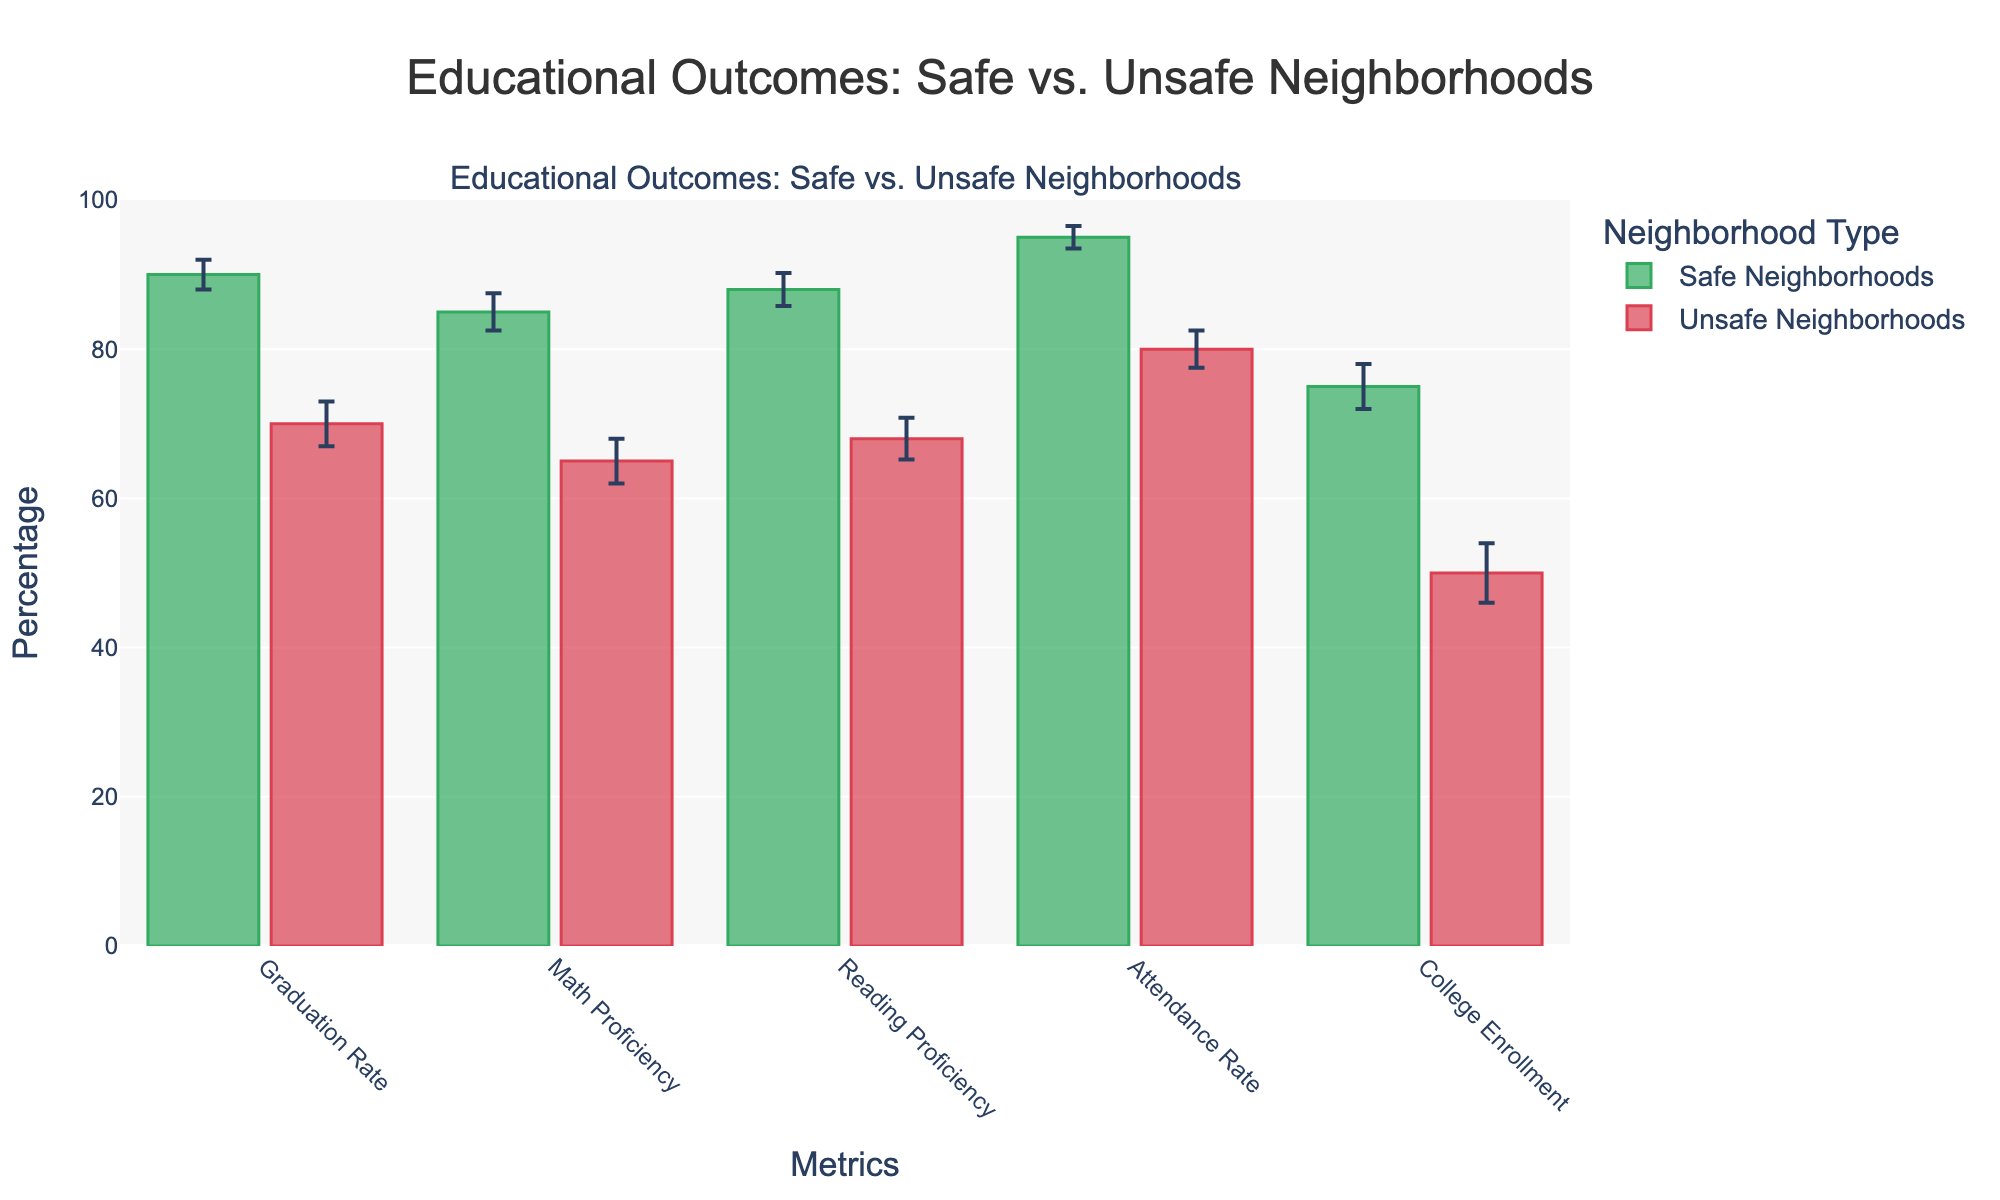What's the title of the figure? The title of the figure is typically displayed at the top and in larger fonts. In this figure, the title is: "Educational Outcomes: Safe vs. Unsafe Neighborhoods".
Answer: Educational Outcomes: Safe vs. Unsafe Neighborhoods What is the mean graduation rate for unsafe neighborhoods? The mean graduation rate for unsafe neighborhoods is shown as the height of the bar labeled "Graduation Rate" under the Unsafe group.
Answer: 70% How does the error bar for reading proficiency in unsafe neighborhoods compare to the error bar for reading proficiency in safe neighborhoods? To compare the error bars for reading proficiency, look at the lines extending vertically from the top of the bars for both safe and unsafe neighborhoods. The error bar in unsafe neighborhoods is larger (2.8) compared to safe neighborhoods (2.2).
Answer: The error bar is larger for unsafe neighborhoods Compare the attendance rates between safe and unsafe neighborhoods. The attendance rate for safe neighborhoods and unsafe neighborhoods is represented by the height of the respective bars. Safe neighborhoods have an attendance rate of 95%, and unsafe neighborhoods have an attendance rate of 80%.
Answer: Safe neighborhoods have a 15% higher attendance rate Which metric shows the smallest difference in means between safe and unsafe neighborhoods? To find this, examine the differences in bar heights for each metric. The smallest difference is in the "Graduation Rate" with a difference of 20 percentage points (90% - 70%).
Answer: Graduation Rate What is the range of y-axis values displayed in the figure? The y-axis range can be seen on the side of the figure where the axis labels are displayed. In this figure, it ranges from 0 to 100.
Answer: 0 to 100 How does college enrollment in safe neighborhoods compare to the overall average college enrollment across both neighborhood types? First calculate the overall average: (75 + 50) / 2 = 62.5%. Then compare this to the college enrollment in safe neighborhoods (75%). The college enrollment in safe neighborhoods is higher than the overall average.
Answer: Higher Which metric has the highest error margin in unsafe neighborhoods? Look at the vertical error bars for each metric under unsafe neighborhoods. The metric "College Enrollment" has the highest error margin of 4%.
Answer: College Enrollment Calculate the mean reading proficiency rate combining both safe and unsafe neighborhoods. Adding the means of reading proficiency for both neighborhoods: (88 + 68) = 156. Dividing by 2 to find the mean: 156 / 2 = 78%.
Answer: 78% What is the difference in math proficiency rates between safe and unsafe neighborhoods? The math proficiency rate is 85% for safe neighborhoods and 65% for unsafe neighborhoods. The difference is calculated as 85% - 65% = 20%.
Answer: 20% Which neighborhood type has higher graduation and attendance rates across all categories? By visually inspecting both the graduation and attendance bars, safe neighborhoods consistently have higher rates in both categories compared to unsafe neighborhoods.
Answer: Safe 